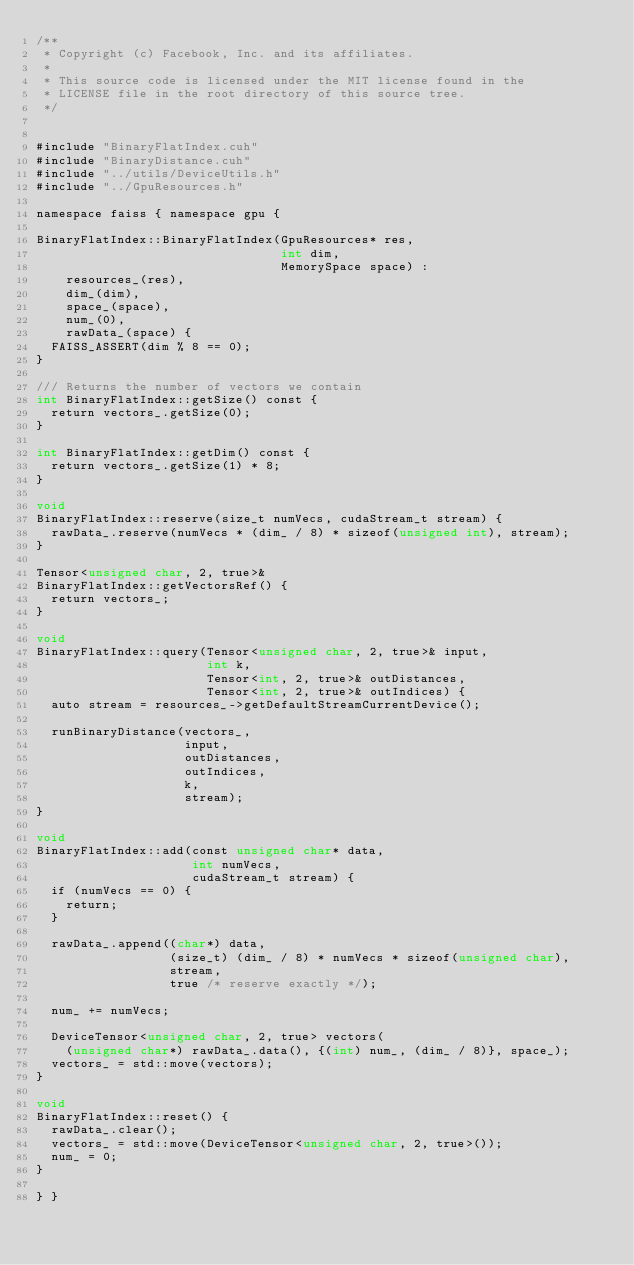<code> <loc_0><loc_0><loc_500><loc_500><_Cuda_>/**
 * Copyright (c) Facebook, Inc. and its affiliates.
 *
 * This source code is licensed under the MIT license found in the
 * LICENSE file in the root directory of this source tree.
 */


#include "BinaryFlatIndex.cuh"
#include "BinaryDistance.cuh"
#include "../utils/DeviceUtils.h"
#include "../GpuResources.h"

namespace faiss { namespace gpu {

BinaryFlatIndex::BinaryFlatIndex(GpuResources* res,
                                 int dim,
                                 MemorySpace space) :
    resources_(res),
    dim_(dim),
    space_(space),
    num_(0),
    rawData_(space) {
  FAISS_ASSERT(dim % 8 == 0);
}

/// Returns the number of vectors we contain
int BinaryFlatIndex::getSize() const {
  return vectors_.getSize(0);
}

int BinaryFlatIndex::getDim() const {
  return vectors_.getSize(1) * 8;
}

void
BinaryFlatIndex::reserve(size_t numVecs, cudaStream_t stream) {
  rawData_.reserve(numVecs * (dim_ / 8) * sizeof(unsigned int), stream);
}

Tensor<unsigned char, 2, true>&
BinaryFlatIndex::getVectorsRef() {
  return vectors_;
}

void
BinaryFlatIndex::query(Tensor<unsigned char, 2, true>& input,
                       int k,
                       Tensor<int, 2, true>& outDistances,
                       Tensor<int, 2, true>& outIndices) {
  auto stream = resources_->getDefaultStreamCurrentDevice();

  runBinaryDistance(vectors_,
                    input,
                    outDistances,
                    outIndices,
                    k,
                    stream);
}

void
BinaryFlatIndex::add(const unsigned char* data,
                     int numVecs,
                     cudaStream_t stream) {
  if (numVecs == 0) {
    return;
  }

  rawData_.append((char*) data,
                  (size_t) (dim_ / 8) * numVecs * sizeof(unsigned char),
                  stream,
                  true /* reserve exactly */);

  num_ += numVecs;

  DeviceTensor<unsigned char, 2, true> vectors(
    (unsigned char*) rawData_.data(), {(int) num_, (dim_ / 8)}, space_);
  vectors_ = std::move(vectors);
}

void
BinaryFlatIndex::reset() {
  rawData_.clear();
  vectors_ = std::move(DeviceTensor<unsigned char, 2, true>());
  num_ = 0;
}

} }
</code> 